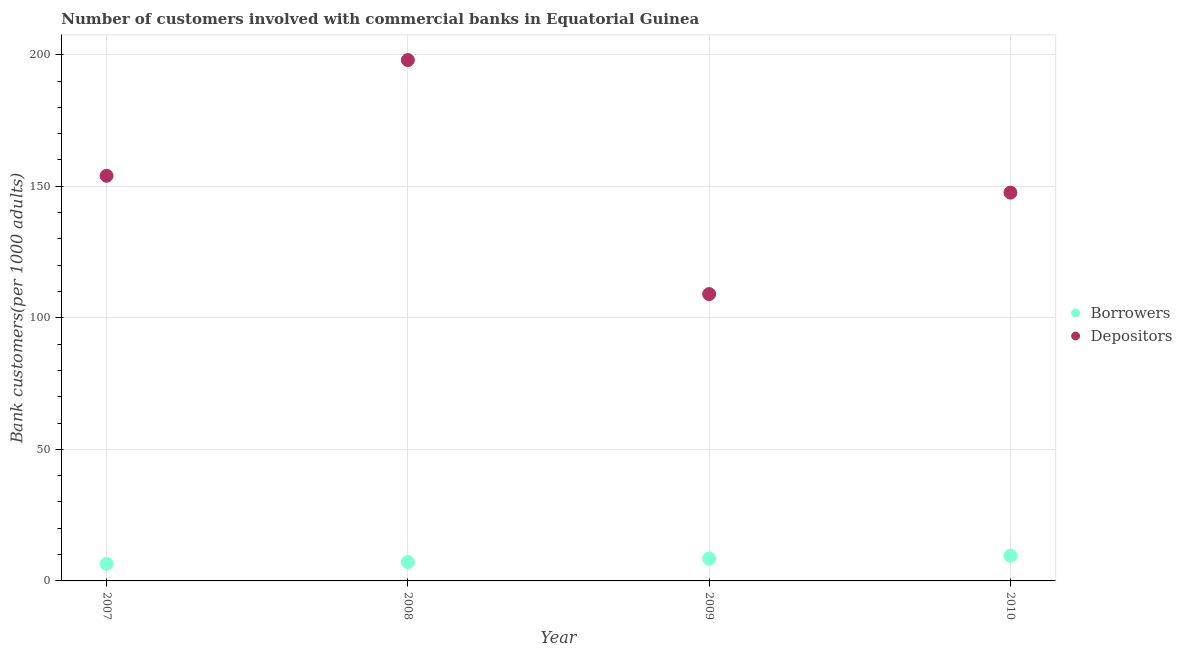What is the number of borrowers in 2008?
Your answer should be compact. 7.17. Across all years, what is the maximum number of depositors?
Offer a terse response. 197.96. Across all years, what is the minimum number of depositors?
Provide a short and direct response. 109.02. In which year was the number of depositors maximum?
Offer a terse response. 2008. In which year was the number of depositors minimum?
Give a very brief answer. 2009. What is the total number of depositors in the graph?
Provide a short and direct response. 608.52. What is the difference between the number of borrowers in 2009 and that in 2010?
Your answer should be very brief. -1.09. What is the difference between the number of depositors in 2007 and the number of borrowers in 2009?
Offer a terse response. 145.48. What is the average number of depositors per year?
Offer a very short reply. 152.13. In the year 2008, what is the difference between the number of borrowers and number of depositors?
Your response must be concise. -190.79. What is the ratio of the number of borrowers in 2007 to that in 2009?
Keep it short and to the point. 0.76. Is the number of borrowers in 2009 less than that in 2010?
Provide a succinct answer. Yes. Is the difference between the number of depositors in 2009 and 2010 greater than the difference between the number of borrowers in 2009 and 2010?
Offer a very short reply. No. What is the difference between the highest and the second highest number of borrowers?
Your answer should be compact. 1.09. What is the difference between the highest and the lowest number of borrowers?
Give a very brief answer. 3.09. In how many years, is the number of borrowers greater than the average number of borrowers taken over all years?
Your response must be concise. 2. Is the sum of the number of depositors in 2007 and 2010 greater than the maximum number of borrowers across all years?
Offer a terse response. Yes. Does the number of borrowers monotonically increase over the years?
Provide a succinct answer. Yes. Is the number of borrowers strictly greater than the number of depositors over the years?
Your answer should be very brief. No. Is the number of borrowers strictly less than the number of depositors over the years?
Give a very brief answer. Yes. How many years are there in the graph?
Ensure brevity in your answer.  4. What is the difference between two consecutive major ticks on the Y-axis?
Your answer should be very brief. 50. How many legend labels are there?
Offer a very short reply. 2. How are the legend labels stacked?
Make the answer very short. Vertical. What is the title of the graph?
Give a very brief answer. Number of customers involved with commercial banks in Equatorial Guinea. Does "Urban" appear as one of the legend labels in the graph?
Your answer should be very brief. No. What is the label or title of the X-axis?
Offer a very short reply. Year. What is the label or title of the Y-axis?
Make the answer very short. Bank customers(per 1000 adults). What is the Bank customers(per 1000 adults) in Borrowers in 2007?
Your answer should be very brief. 6.49. What is the Bank customers(per 1000 adults) of Depositors in 2007?
Ensure brevity in your answer.  153.97. What is the Bank customers(per 1000 adults) in Borrowers in 2008?
Provide a short and direct response. 7.17. What is the Bank customers(per 1000 adults) of Depositors in 2008?
Your response must be concise. 197.96. What is the Bank customers(per 1000 adults) in Borrowers in 2009?
Ensure brevity in your answer.  8.49. What is the Bank customers(per 1000 adults) in Depositors in 2009?
Offer a very short reply. 109.02. What is the Bank customers(per 1000 adults) of Borrowers in 2010?
Your answer should be very brief. 9.58. What is the Bank customers(per 1000 adults) of Depositors in 2010?
Your answer should be compact. 147.57. Across all years, what is the maximum Bank customers(per 1000 adults) in Borrowers?
Your answer should be compact. 9.58. Across all years, what is the maximum Bank customers(per 1000 adults) in Depositors?
Make the answer very short. 197.96. Across all years, what is the minimum Bank customers(per 1000 adults) of Borrowers?
Make the answer very short. 6.49. Across all years, what is the minimum Bank customers(per 1000 adults) of Depositors?
Provide a short and direct response. 109.02. What is the total Bank customers(per 1000 adults) in Borrowers in the graph?
Keep it short and to the point. 31.73. What is the total Bank customers(per 1000 adults) in Depositors in the graph?
Offer a very short reply. 608.52. What is the difference between the Bank customers(per 1000 adults) of Borrowers in 2007 and that in 2008?
Provide a short and direct response. -0.69. What is the difference between the Bank customers(per 1000 adults) in Depositors in 2007 and that in 2008?
Offer a terse response. -43.99. What is the difference between the Bank customers(per 1000 adults) in Borrowers in 2007 and that in 2009?
Your answer should be compact. -2. What is the difference between the Bank customers(per 1000 adults) in Depositors in 2007 and that in 2009?
Your answer should be compact. 44.95. What is the difference between the Bank customers(per 1000 adults) in Borrowers in 2007 and that in 2010?
Provide a short and direct response. -3.09. What is the difference between the Bank customers(per 1000 adults) of Depositors in 2007 and that in 2010?
Provide a succinct answer. 6.4. What is the difference between the Bank customers(per 1000 adults) of Borrowers in 2008 and that in 2009?
Provide a succinct answer. -1.31. What is the difference between the Bank customers(per 1000 adults) of Depositors in 2008 and that in 2009?
Your response must be concise. 88.94. What is the difference between the Bank customers(per 1000 adults) in Borrowers in 2008 and that in 2010?
Offer a terse response. -2.4. What is the difference between the Bank customers(per 1000 adults) of Depositors in 2008 and that in 2010?
Your answer should be compact. 50.39. What is the difference between the Bank customers(per 1000 adults) of Borrowers in 2009 and that in 2010?
Make the answer very short. -1.09. What is the difference between the Bank customers(per 1000 adults) of Depositors in 2009 and that in 2010?
Give a very brief answer. -38.55. What is the difference between the Bank customers(per 1000 adults) of Borrowers in 2007 and the Bank customers(per 1000 adults) of Depositors in 2008?
Keep it short and to the point. -191.47. What is the difference between the Bank customers(per 1000 adults) of Borrowers in 2007 and the Bank customers(per 1000 adults) of Depositors in 2009?
Offer a terse response. -102.53. What is the difference between the Bank customers(per 1000 adults) of Borrowers in 2007 and the Bank customers(per 1000 adults) of Depositors in 2010?
Offer a very short reply. -141.08. What is the difference between the Bank customers(per 1000 adults) of Borrowers in 2008 and the Bank customers(per 1000 adults) of Depositors in 2009?
Make the answer very short. -101.84. What is the difference between the Bank customers(per 1000 adults) in Borrowers in 2008 and the Bank customers(per 1000 adults) in Depositors in 2010?
Offer a terse response. -140.4. What is the difference between the Bank customers(per 1000 adults) of Borrowers in 2009 and the Bank customers(per 1000 adults) of Depositors in 2010?
Keep it short and to the point. -139.08. What is the average Bank customers(per 1000 adults) of Borrowers per year?
Your answer should be compact. 7.93. What is the average Bank customers(per 1000 adults) in Depositors per year?
Offer a very short reply. 152.13. In the year 2007, what is the difference between the Bank customers(per 1000 adults) in Borrowers and Bank customers(per 1000 adults) in Depositors?
Offer a terse response. -147.48. In the year 2008, what is the difference between the Bank customers(per 1000 adults) in Borrowers and Bank customers(per 1000 adults) in Depositors?
Your answer should be very brief. -190.79. In the year 2009, what is the difference between the Bank customers(per 1000 adults) in Borrowers and Bank customers(per 1000 adults) in Depositors?
Your answer should be compact. -100.53. In the year 2010, what is the difference between the Bank customers(per 1000 adults) in Borrowers and Bank customers(per 1000 adults) in Depositors?
Offer a terse response. -137.99. What is the ratio of the Bank customers(per 1000 adults) of Borrowers in 2007 to that in 2008?
Your answer should be very brief. 0.9. What is the ratio of the Bank customers(per 1000 adults) in Borrowers in 2007 to that in 2009?
Provide a short and direct response. 0.76. What is the ratio of the Bank customers(per 1000 adults) in Depositors in 2007 to that in 2009?
Your response must be concise. 1.41. What is the ratio of the Bank customers(per 1000 adults) in Borrowers in 2007 to that in 2010?
Your answer should be compact. 0.68. What is the ratio of the Bank customers(per 1000 adults) of Depositors in 2007 to that in 2010?
Keep it short and to the point. 1.04. What is the ratio of the Bank customers(per 1000 adults) in Borrowers in 2008 to that in 2009?
Ensure brevity in your answer.  0.85. What is the ratio of the Bank customers(per 1000 adults) in Depositors in 2008 to that in 2009?
Provide a short and direct response. 1.82. What is the ratio of the Bank customers(per 1000 adults) of Borrowers in 2008 to that in 2010?
Give a very brief answer. 0.75. What is the ratio of the Bank customers(per 1000 adults) of Depositors in 2008 to that in 2010?
Make the answer very short. 1.34. What is the ratio of the Bank customers(per 1000 adults) in Borrowers in 2009 to that in 2010?
Make the answer very short. 0.89. What is the ratio of the Bank customers(per 1000 adults) in Depositors in 2009 to that in 2010?
Offer a very short reply. 0.74. What is the difference between the highest and the second highest Bank customers(per 1000 adults) of Borrowers?
Ensure brevity in your answer.  1.09. What is the difference between the highest and the second highest Bank customers(per 1000 adults) of Depositors?
Provide a succinct answer. 43.99. What is the difference between the highest and the lowest Bank customers(per 1000 adults) of Borrowers?
Give a very brief answer. 3.09. What is the difference between the highest and the lowest Bank customers(per 1000 adults) of Depositors?
Provide a short and direct response. 88.94. 